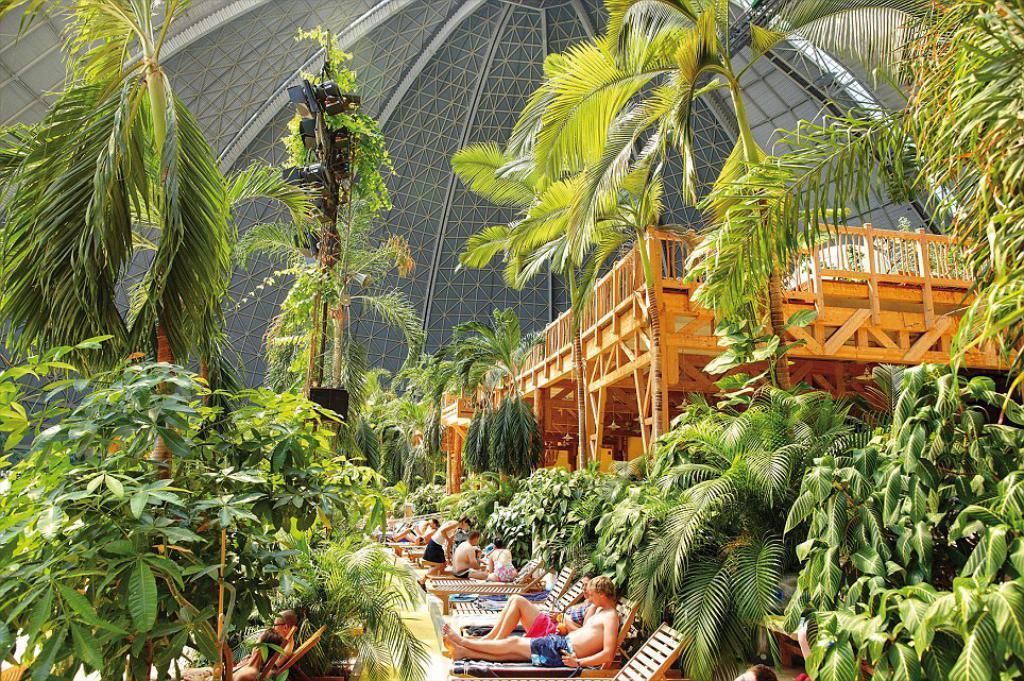How would you summarize this image in a sentence or two? In this image there is a woman walking, there are a group of persons sitting on the wooden objects, there are trees towards the right of the image, there are trees towards the left of the image, there is a wooden object towards the right of the image, there is a roof towards the top of the image. 